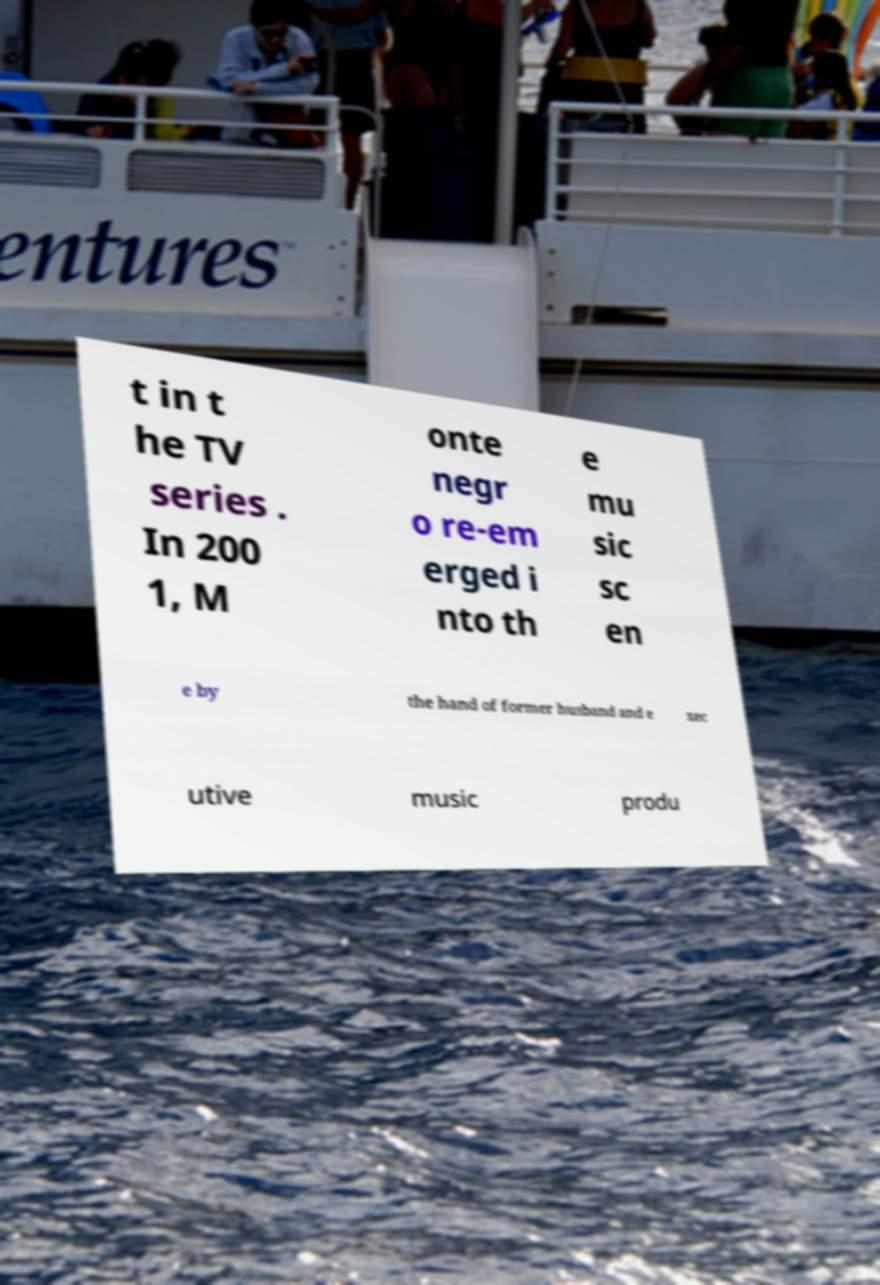Can you read and provide the text displayed in the image?This photo seems to have some interesting text. Can you extract and type it out for me? t in t he TV series . In 200 1, M onte negr o re-em erged i nto th e mu sic sc en e by the hand of former husband and e xec utive music produ 